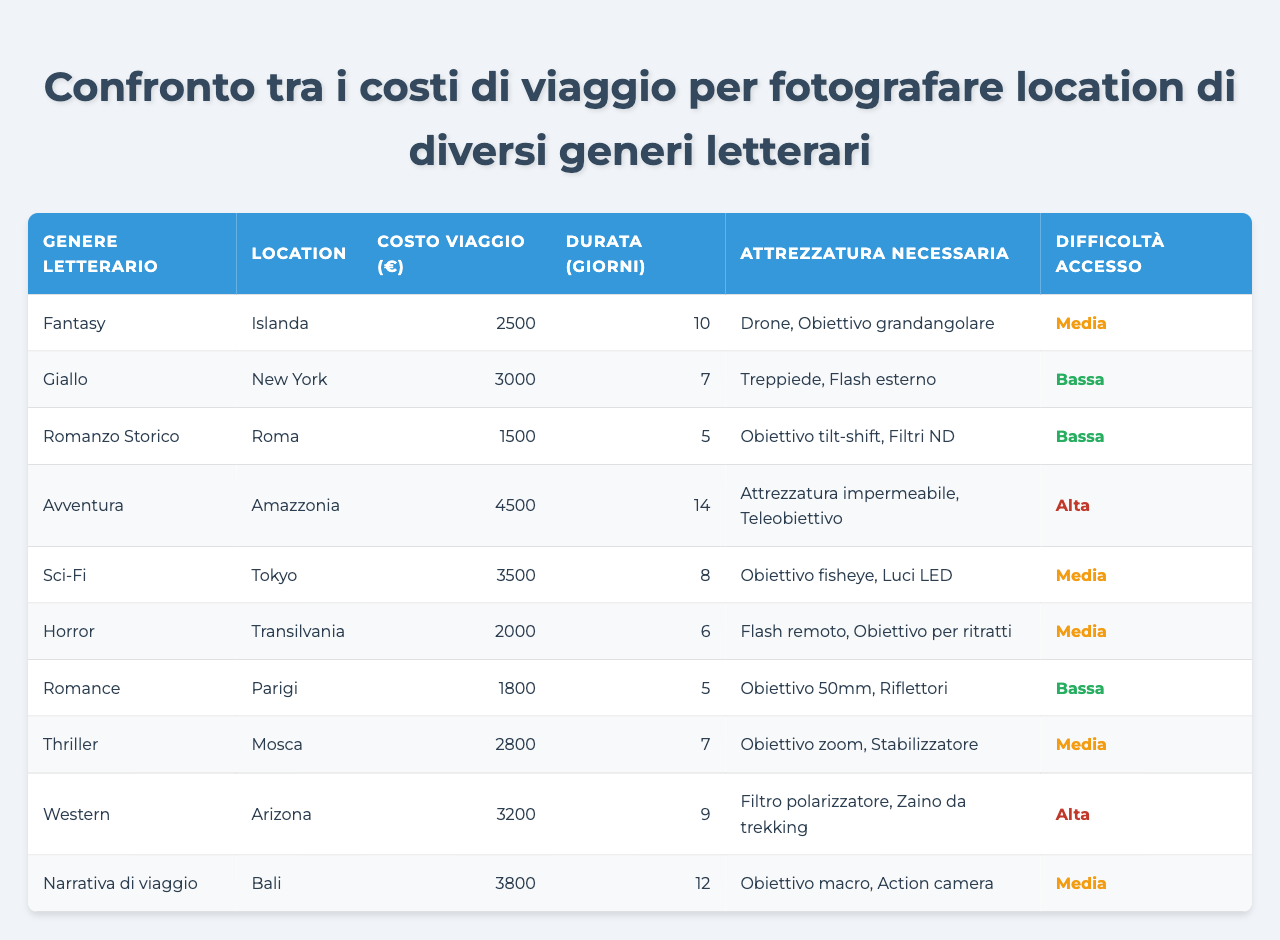Qual è la location più economica per viaggiare e fotografare? Guardando la colonna "Costo Viaggio (€)", la location con il costo più basso è Roma con 1500 euro.
Answer: Roma Quanti giorni trascorreresti mediamente per fotografare un genere letterario che ha una difficoltà di accesso media? Le location con "Difficoltà Accesso" media sono Islanda, Tokyo, Horror e Thriller. Sommiamo i giorni: 10 (Islanda) + 8 (Tokyo) + 6 (Horror) + 7 (Thriller) = 31 giorni. Dividiamo per 4 per trovare la media: 31/4 = 7.75 giorni.
Answer: 7.75 giorni Qual è il costo totale per viaggiare a Bali e a New York? Sommiamo i costi di Bali (3800 euro) e New York (3000 euro): 3800 + 3000 = 6800 euro.
Answer: 6800 euro C'è un genere letterario che richiede un'attrezzatura diversa da un obiettivo? Sì, per Avventura è necessario attrezzatura impermeabile e teleobiettivo, mentre per Giallo è richiesto un treppiede e un flash esterno.
Answer: Sì Quali generi letterari hanno costi di viaggio superiori alla media di tutti i generi? Calcoliamo la media dei costi: (2500 + 3000 + 1500 + 4500 + 3500 + 2000 + 1800 + 2800 + 3200 + 3800) / 10 = 2770 euro. I generi con costi superiori sono Giallo, Avventura, Sci-Fi, e Narrativa di viaggio.
Answer: Giallo, Avventura, Sci-Fi, Narrativa di viaggio Qual è la location con il costo più alto e quale attrezzatura è necessaria? La location con il costo più alto è l'Amazzonia, con un costo di 4500 euro, e l'attrezzatura necessaria è impermeabile e teleobiettivo.
Answer: Amazzonia, attrezzatura impermeabile e teleobiettivo 